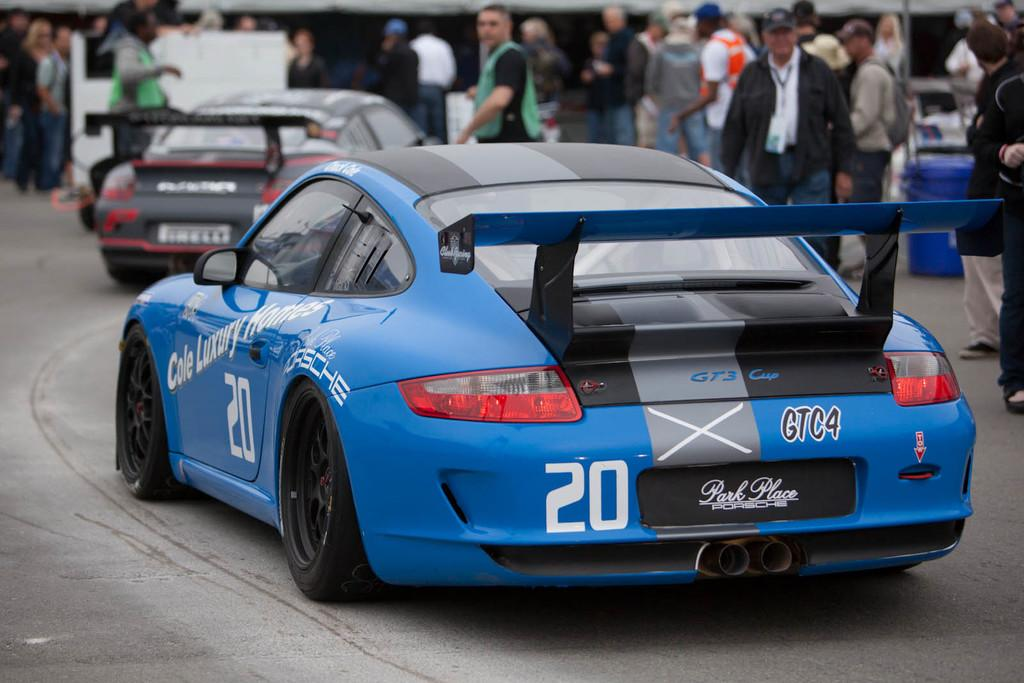How many cars are visible in the image? There are two cars in the image. Where are the cars located? The cars are on the road. Are there any other vehicles or objects visible on the road? The provided facts do not mention any other vehicles or objects on the road. What else can be seen in the background of the image? There are many people standing on the road in the background. What type of popcorn is being served at the fight in the image? There is no popcorn or fight present in the image. What color is the cup that the person is holding in the image? There is no cup or person holding a cup present in the image. 